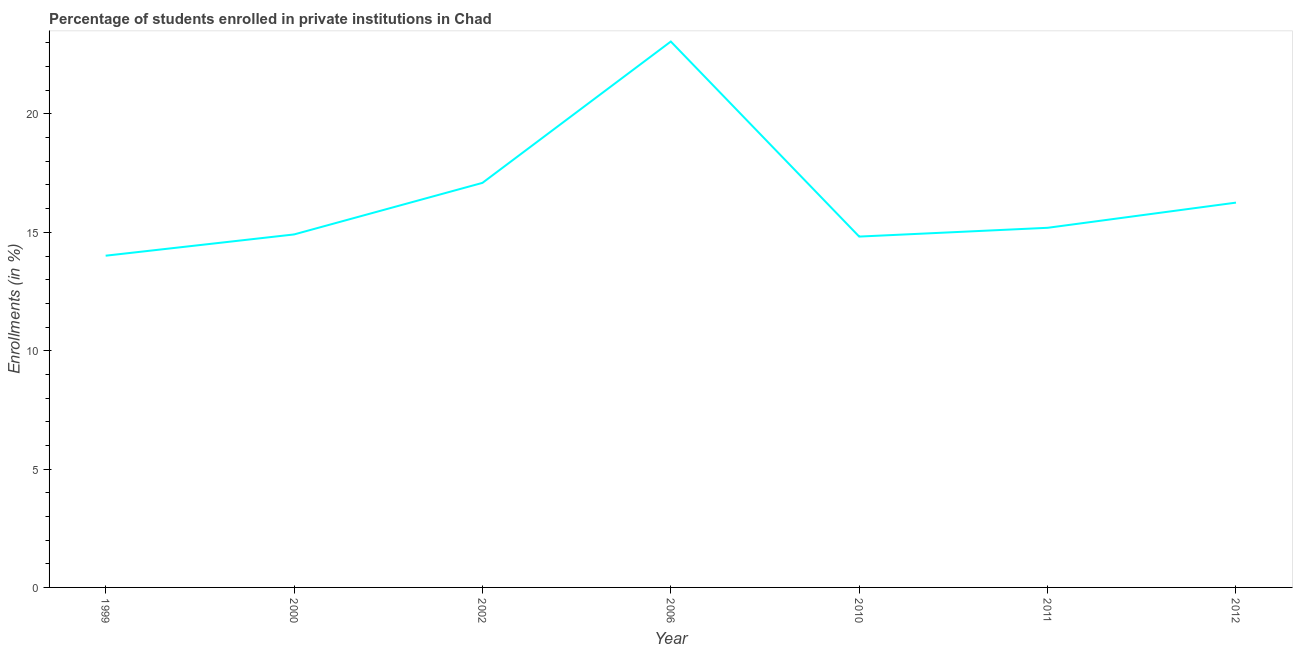What is the enrollments in private institutions in 2012?
Give a very brief answer. 16.26. Across all years, what is the maximum enrollments in private institutions?
Your answer should be very brief. 23.06. Across all years, what is the minimum enrollments in private institutions?
Keep it short and to the point. 14.01. In which year was the enrollments in private institutions minimum?
Give a very brief answer. 1999. What is the sum of the enrollments in private institutions?
Offer a very short reply. 115.34. What is the difference between the enrollments in private institutions in 1999 and 2006?
Provide a short and direct response. -9.05. What is the average enrollments in private institutions per year?
Ensure brevity in your answer.  16.48. What is the median enrollments in private institutions?
Offer a very short reply. 15.19. What is the ratio of the enrollments in private institutions in 2010 to that in 2012?
Provide a succinct answer. 0.91. Is the enrollments in private institutions in 1999 less than that in 2002?
Your response must be concise. Yes. What is the difference between the highest and the second highest enrollments in private institutions?
Give a very brief answer. 5.97. What is the difference between the highest and the lowest enrollments in private institutions?
Provide a short and direct response. 9.05. In how many years, is the enrollments in private institutions greater than the average enrollments in private institutions taken over all years?
Keep it short and to the point. 2. Does the enrollments in private institutions monotonically increase over the years?
Your answer should be compact. No. How many years are there in the graph?
Your response must be concise. 7. Are the values on the major ticks of Y-axis written in scientific E-notation?
Your answer should be very brief. No. What is the title of the graph?
Provide a short and direct response. Percentage of students enrolled in private institutions in Chad. What is the label or title of the X-axis?
Provide a succinct answer. Year. What is the label or title of the Y-axis?
Provide a succinct answer. Enrollments (in %). What is the Enrollments (in %) of 1999?
Provide a succinct answer. 14.01. What is the Enrollments (in %) of 2000?
Offer a very short reply. 14.91. What is the Enrollments (in %) in 2002?
Give a very brief answer. 17.09. What is the Enrollments (in %) of 2006?
Provide a succinct answer. 23.06. What is the Enrollments (in %) in 2010?
Your response must be concise. 14.82. What is the Enrollments (in %) in 2011?
Provide a short and direct response. 15.19. What is the Enrollments (in %) of 2012?
Provide a succinct answer. 16.26. What is the difference between the Enrollments (in %) in 1999 and 2000?
Offer a terse response. -0.9. What is the difference between the Enrollments (in %) in 1999 and 2002?
Give a very brief answer. -3.08. What is the difference between the Enrollments (in %) in 1999 and 2006?
Your response must be concise. -9.05. What is the difference between the Enrollments (in %) in 1999 and 2010?
Your answer should be compact. -0.81. What is the difference between the Enrollments (in %) in 1999 and 2011?
Make the answer very short. -1.18. What is the difference between the Enrollments (in %) in 1999 and 2012?
Provide a succinct answer. -2.24. What is the difference between the Enrollments (in %) in 2000 and 2002?
Your answer should be very brief. -2.18. What is the difference between the Enrollments (in %) in 2000 and 2006?
Your answer should be compact. -8.15. What is the difference between the Enrollments (in %) in 2000 and 2010?
Ensure brevity in your answer.  0.09. What is the difference between the Enrollments (in %) in 2000 and 2011?
Give a very brief answer. -0.28. What is the difference between the Enrollments (in %) in 2000 and 2012?
Keep it short and to the point. -1.34. What is the difference between the Enrollments (in %) in 2002 and 2006?
Provide a short and direct response. -5.97. What is the difference between the Enrollments (in %) in 2002 and 2010?
Offer a terse response. 2.27. What is the difference between the Enrollments (in %) in 2002 and 2011?
Ensure brevity in your answer.  1.9. What is the difference between the Enrollments (in %) in 2002 and 2012?
Make the answer very short. 0.83. What is the difference between the Enrollments (in %) in 2006 and 2010?
Provide a short and direct response. 8.24. What is the difference between the Enrollments (in %) in 2006 and 2011?
Your response must be concise. 7.87. What is the difference between the Enrollments (in %) in 2006 and 2012?
Provide a succinct answer. 6.8. What is the difference between the Enrollments (in %) in 2010 and 2011?
Provide a short and direct response. -0.37. What is the difference between the Enrollments (in %) in 2010 and 2012?
Give a very brief answer. -1.43. What is the difference between the Enrollments (in %) in 2011 and 2012?
Your response must be concise. -1.06. What is the ratio of the Enrollments (in %) in 1999 to that in 2002?
Provide a short and direct response. 0.82. What is the ratio of the Enrollments (in %) in 1999 to that in 2006?
Your response must be concise. 0.61. What is the ratio of the Enrollments (in %) in 1999 to that in 2010?
Give a very brief answer. 0.94. What is the ratio of the Enrollments (in %) in 1999 to that in 2011?
Your answer should be very brief. 0.92. What is the ratio of the Enrollments (in %) in 1999 to that in 2012?
Give a very brief answer. 0.86. What is the ratio of the Enrollments (in %) in 2000 to that in 2002?
Your answer should be very brief. 0.87. What is the ratio of the Enrollments (in %) in 2000 to that in 2006?
Your answer should be compact. 0.65. What is the ratio of the Enrollments (in %) in 2000 to that in 2012?
Offer a terse response. 0.92. What is the ratio of the Enrollments (in %) in 2002 to that in 2006?
Make the answer very short. 0.74. What is the ratio of the Enrollments (in %) in 2002 to that in 2010?
Your answer should be compact. 1.15. What is the ratio of the Enrollments (in %) in 2002 to that in 2012?
Ensure brevity in your answer.  1.05. What is the ratio of the Enrollments (in %) in 2006 to that in 2010?
Provide a succinct answer. 1.56. What is the ratio of the Enrollments (in %) in 2006 to that in 2011?
Make the answer very short. 1.52. What is the ratio of the Enrollments (in %) in 2006 to that in 2012?
Make the answer very short. 1.42. What is the ratio of the Enrollments (in %) in 2010 to that in 2012?
Your answer should be very brief. 0.91. What is the ratio of the Enrollments (in %) in 2011 to that in 2012?
Ensure brevity in your answer.  0.94. 